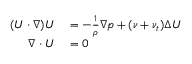<formula> <loc_0><loc_0><loc_500><loc_500>\begin{array} { r l } { ( U \cdot \nabla ) U } & = - \frac { 1 } { \rho } \nabla p + ( \nu + \nu _ { t } ) \Delta U } \\ { \nabla \cdot U } & = 0 } \end{array}</formula> 